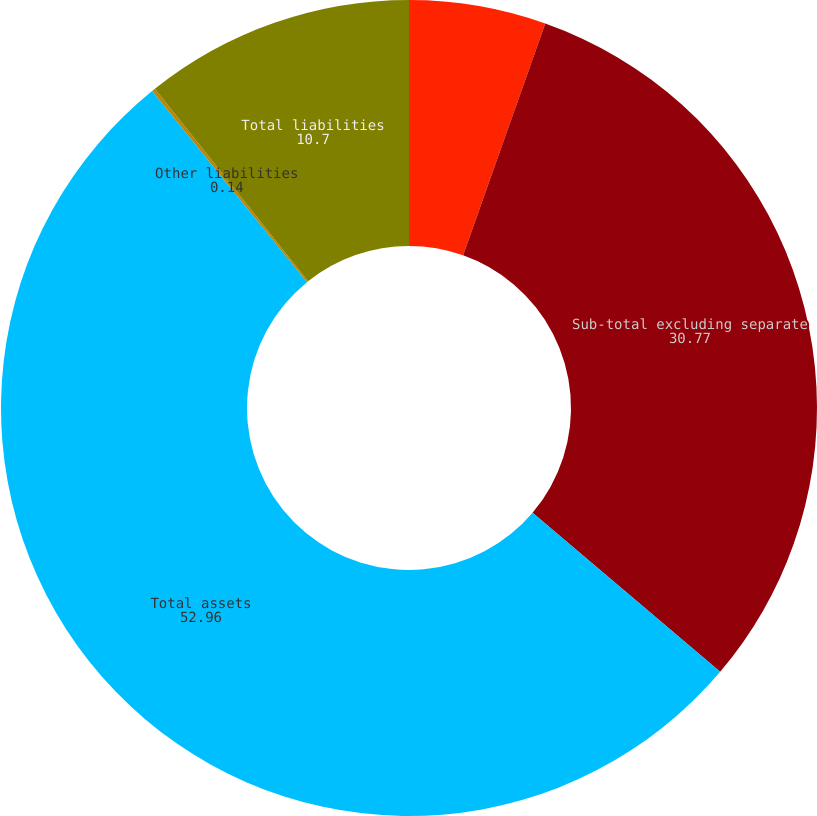<chart> <loc_0><loc_0><loc_500><loc_500><pie_chart><fcel>Other trading account assets<fcel>Sub-total excluding separate<fcel>Total assets<fcel>Other liabilities<fcel>Total liabilities<nl><fcel>5.42%<fcel>30.77%<fcel>52.96%<fcel>0.14%<fcel>10.7%<nl></chart> 